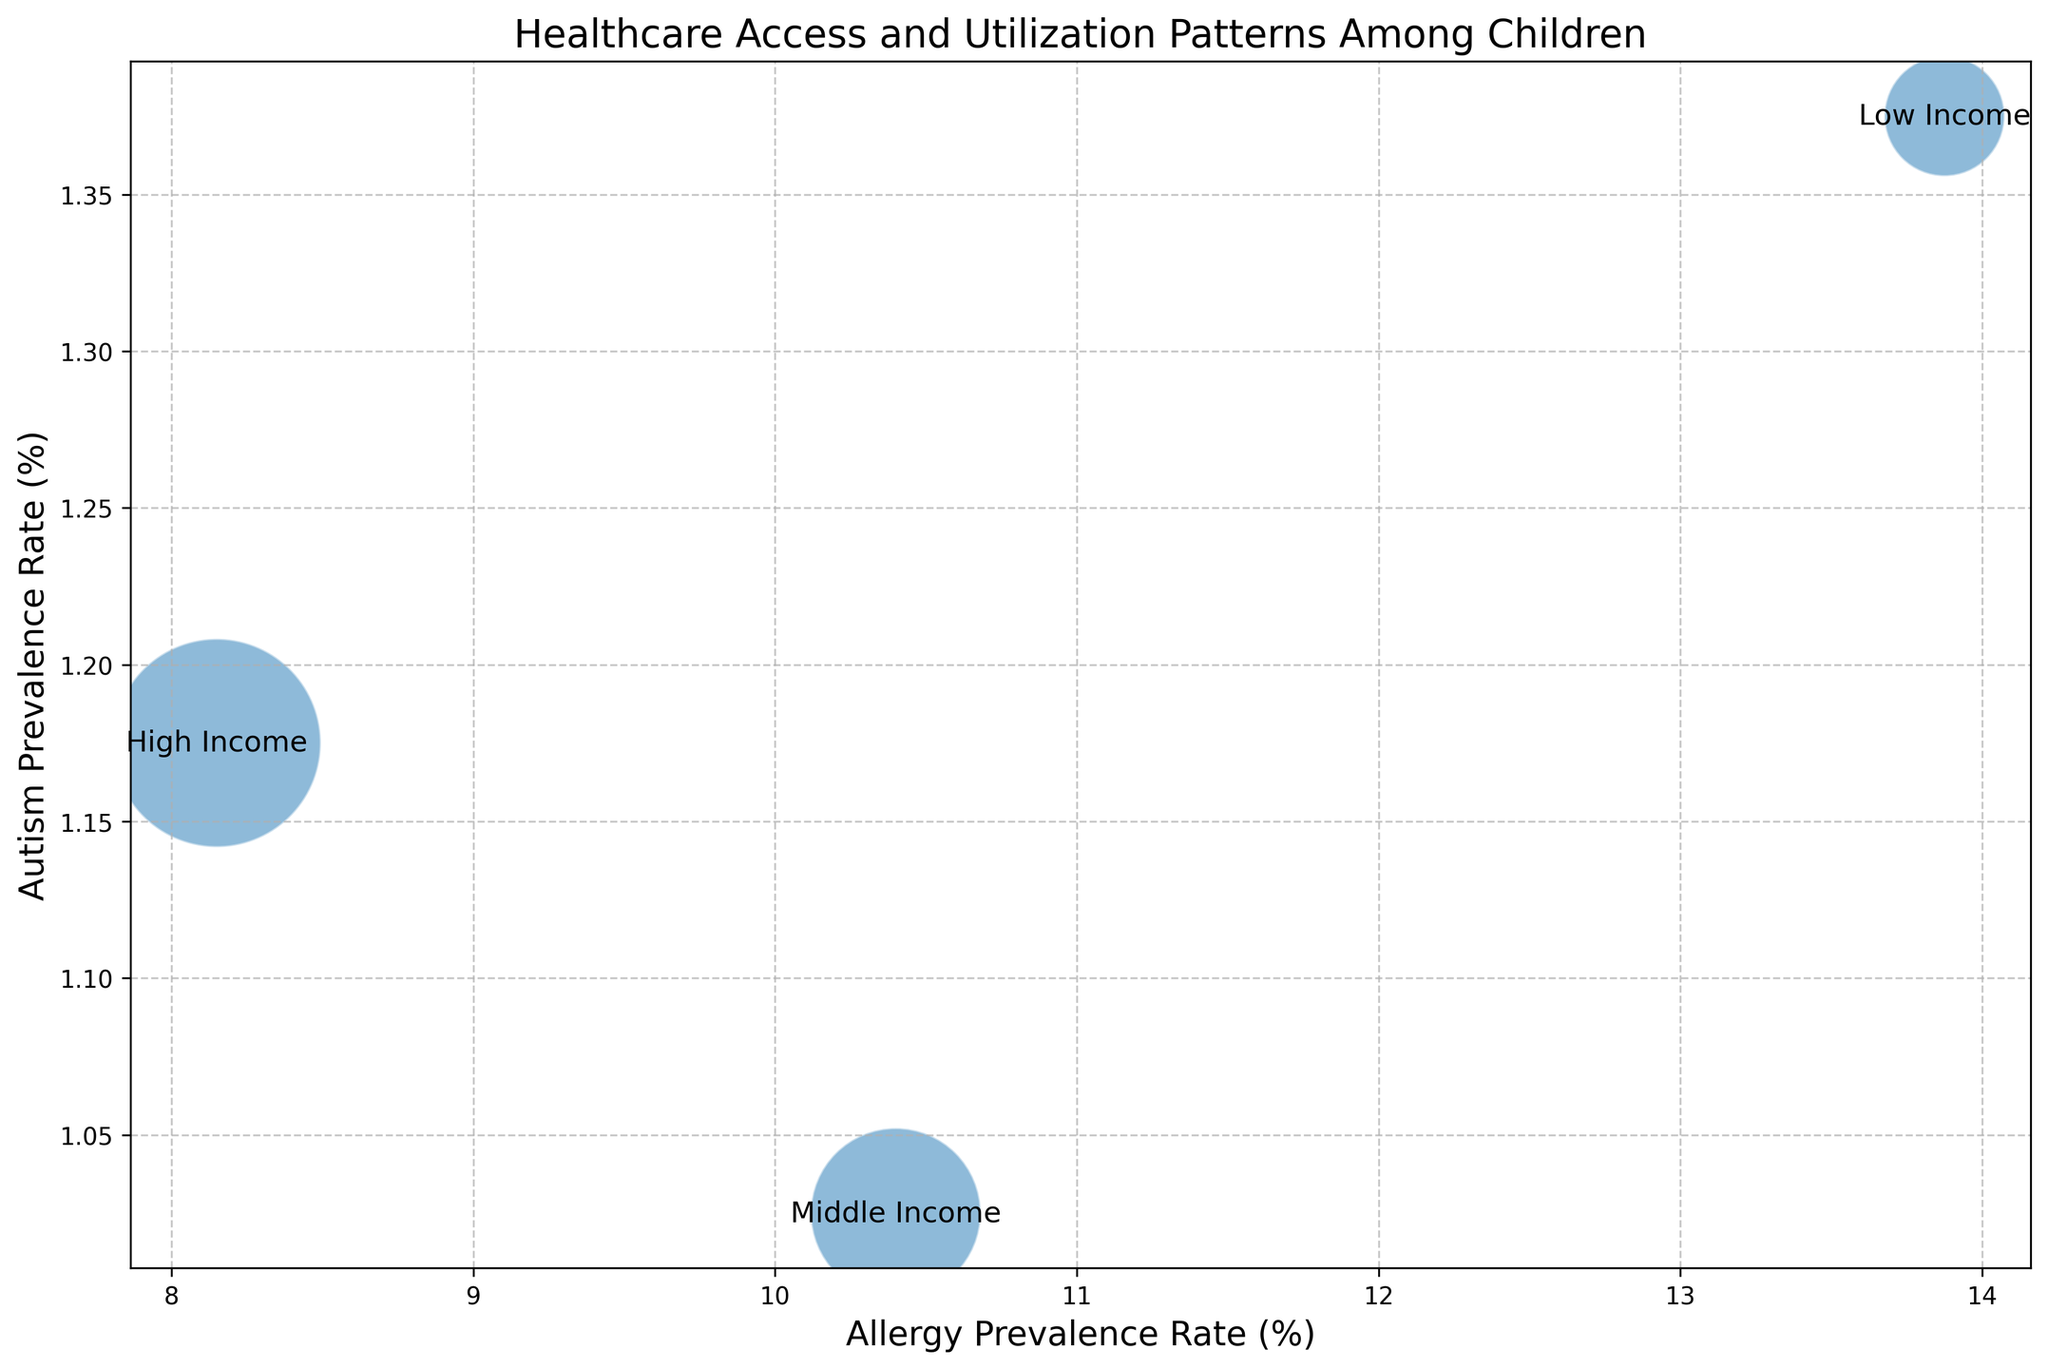Which income level has the highest allergy prevalence rate? To determine the highest allergy prevalence rate, we look for the bubble associated with each income level and check the x-axis. The "Low Income" group has the highest allergy prevalence rate.
Answer: Low Income Which income level has the highest healthcare utilization rate on average? To find this, we look at the y-axis and check which bubble is highest. The "High Income" group has the highest healthcare utilization rate.
Answer: High Income Compare the average autism prevalence rate between middle and high income groups. Which is higher? By examining the y-axis positions of the bubbles for "Middle Income" and "High Income," we can compare their average autism prevalence rates. "High Income" has a slightly higher average autism prevalence rate than "Middle Income."
Answer: High Income Which income level has the smallest bubble size, and what does it represent? Bubble size is tied to median income, so we look for the smallest bubble. The smallest bubbles belong to the "Low Income" group, indicating a median income of $25,000.
Answer: Low Income By how much does the allergy prevalence rate decrease from low income to high income? The average allergy prevalence rate for "Low Income" is around 13.88%, and for "High Income," it is approximately 8.20%. The difference is 13.88% - 8.20% = 5.68%.
Answer: 5.68% What is the ratio of healthcare utilization rates between high income and low income groups? The average healthcare utilization rate for "High Income" is 85.33% and for "Low Income," it is 56.5%. The ratio is 85.33 / 56.5 ≈ 1.51.
Answer: 1.51 Are there any other socioeconomic groups with a similar autism prevalence rate to the high income group? By examining the y-axis locations of the autism prevalence rates, "Low Income" shows a similar rate to "High Income," both around 1.3%.
Answer: Low Income How does healthcare utilization vary as allergy prevalence changes across income levels? In general, as you move from "Low Income" (higher allergy prevalence) to "High Income" (lower allergy prevalence), healthcare utilization rates increase, showing an inverse relationship.
Answer: Increases Estimate the average allergy prevalence rate across all income levels. Summing the average allergy prevalence rates for all income levels (Low: 13.88, Middle: 10.53, High: 8.20) and dividing by three gives (13.88 + 10.53 + 8.20) / 3 ≈ 10.87%.
Answer: 10.87% Which group has a higher variance in allergy prevalence rates, low income or middle income, based on the bubble chart? Given the clustered distances of bubbles along the x-axis, "Low Income" appears to have a higher variance. The allergy prevalence rates for "Low Income" vary more (ranging from 12.5 to15) compared to "Middle Income" (ranging from 9.8 to 11).
Answer: Low Income 